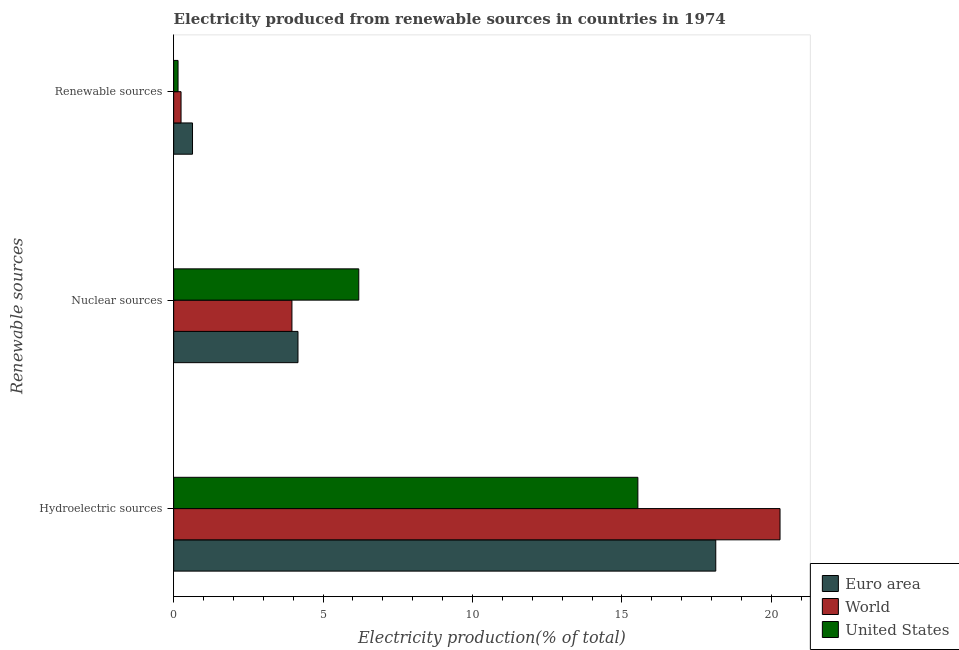Are the number of bars on each tick of the Y-axis equal?
Make the answer very short. Yes. How many bars are there on the 2nd tick from the top?
Provide a succinct answer. 3. What is the label of the 2nd group of bars from the top?
Give a very brief answer. Nuclear sources. What is the percentage of electricity produced by hydroelectric sources in United States?
Provide a short and direct response. 15.54. Across all countries, what is the maximum percentage of electricity produced by renewable sources?
Your response must be concise. 0.63. Across all countries, what is the minimum percentage of electricity produced by nuclear sources?
Your answer should be very brief. 3.96. In which country was the percentage of electricity produced by nuclear sources minimum?
Offer a terse response. World. What is the total percentage of electricity produced by renewable sources in the graph?
Keep it short and to the point. 1.02. What is the difference between the percentage of electricity produced by nuclear sources in Euro area and that in United States?
Provide a short and direct response. -2.03. What is the difference between the percentage of electricity produced by nuclear sources in World and the percentage of electricity produced by hydroelectric sources in Euro area?
Your response must be concise. -14.18. What is the average percentage of electricity produced by hydroelectric sources per country?
Provide a short and direct response. 17.99. What is the difference between the percentage of electricity produced by renewable sources and percentage of electricity produced by hydroelectric sources in Euro area?
Your response must be concise. -17.51. What is the ratio of the percentage of electricity produced by hydroelectric sources in United States to that in Euro area?
Provide a succinct answer. 0.86. Is the percentage of electricity produced by hydroelectric sources in United States less than that in Euro area?
Offer a very short reply. Yes. What is the difference between the highest and the second highest percentage of electricity produced by renewable sources?
Offer a terse response. 0.38. What is the difference between the highest and the lowest percentage of electricity produced by renewable sources?
Offer a terse response. 0.48. In how many countries, is the percentage of electricity produced by renewable sources greater than the average percentage of electricity produced by renewable sources taken over all countries?
Make the answer very short. 1. What does the 3rd bar from the bottom in Nuclear sources represents?
Offer a terse response. United States. Are all the bars in the graph horizontal?
Give a very brief answer. Yes. How many countries are there in the graph?
Your response must be concise. 3. What is the difference between two consecutive major ticks on the X-axis?
Your response must be concise. 5. Does the graph contain any zero values?
Give a very brief answer. No. Does the graph contain grids?
Keep it short and to the point. No. How many legend labels are there?
Your response must be concise. 3. What is the title of the graph?
Your answer should be very brief. Electricity produced from renewable sources in countries in 1974. Does "Central African Republic" appear as one of the legend labels in the graph?
Your response must be concise. No. What is the label or title of the Y-axis?
Provide a short and direct response. Renewable sources. What is the Electricity production(% of total) of Euro area in Hydroelectric sources?
Provide a succinct answer. 18.14. What is the Electricity production(% of total) in World in Hydroelectric sources?
Ensure brevity in your answer.  20.29. What is the Electricity production(% of total) in United States in Hydroelectric sources?
Make the answer very short. 15.54. What is the Electricity production(% of total) in Euro area in Nuclear sources?
Ensure brevity in your answer.  4.16. What is the Electricity production(% of total) in World in Nuclear sources?
Your answer should be compact. 3.96. What is the Electricity production(% of total) in United States in Nuclear sources?
Provide a short and direct response. 6.19. What is the Electricity production(% of total) of Euro area in Renewable sources?
Offer a terse response. 0.63. What is the Electricity production(% of total) in World in Renewable sources?
Offer a very short reply. 0.25. What is the Electricity production(% of total) of United States in Renewable sources?
Your answer should be compact. 0.15. Across all Renewable sources, what is the maximum Electricity production(% of total) in Euro area?
Your response must be concise. 18.14. Across all Renewable sources, what is the maximum Electricity production(% of total) in World?
Ensure brevity in your answer.  20.29. Across all Renewable sources, what is the maximum Electricity production(% of total) of United States?
Make the answer very short. 15.54. Across all Renewable sources, what is the minimum Electricity production(% of total) of Euro area?
Keep it short and to the point. 0.63. Across all Renewable sources, what is the minimum Electricity production(% of total) in World?
Your answer should be compact. 0.25. Across all Renewable sources, what is the minimum Electricity production(% of total) in United States?
Make the answer very short. 0.15. What is the total Electricity production(% of total) of Euro area in the graph?
Give a very brief answer. 22.93. What is the total Electricity production(% of total) in World in the graph?
Your answer should be very brief. 24.5. What is the total Electricity production(% of total) of United States in the graph?
Offer a terse response. 21.88. What is the difference between the Electricity production(% of total) of Euro area in Hydroelectric sources and that in Nuclear sources?
Keep it short and to the point. 13.98. What is the difference between the Electricity production(% of total) of World in Hydroelectric sources and that in Nuclear sources?
Your answer should be compact. 16.33. What is the difference between the Electricity production(% of total) of United States in Hydroelectric sources and that in Nuclear sources?
Ensure brevity in your answer.  9.34. What is the difference between the Electricity production(% of total) in Euro area in Hydroelectric sources and that in Renewable sources?
Give a very brief answer. 17.51. What is the difference between the Electricity production(% of total) in World in Hydroelectric sources and that in Renewable sources?
Ensure brevity in your answer.  20.05. What is the difference between the Electricity production(% of total) of United States in Hydroelectric sources and that in Renewable sources?
Ensure brevity in your answer.  15.39. What is the difference between the Electricity production(% of total) of Euro area in Nuclear sources and that in Renewable sources?
Give a very brief answer. 3.53. What is the difference between the Electricity production(% of total) of World in Nuclear sources and that in Renewable sources?
Ensure brevity in your answer.  3.71. What is the difference between the Electricity production(% of total) of United States in Nuclear sources and that in Renewable sources?
Provide a short and direct response. 6.05. What is the difference between the Electricity production(% of total) in Euro area in Hydroelectric sources and the Electricity production(% of total) in World in Nuclear sources?
Provide a succinct answer. 14.18. What is the difference between the Electricity production(% of total) of Euro area in Hydroelectric sources and the Electricity production(% of total) of United States in Nuclear sources?
Provide a short and direct response. 11.95. What is the difference between the Electricity production(% of total) of World in Hydroelectric sources and the Electricity production(% of total) of United States in Nuclear sources?
Offer a very short reply. 14.1. What is the difference between the Electricity production(% of total) of Euro area in Hydroelectric sources and the Electricity production(% of total) of World in Renewable sources?
Provide a succinct answer. 17.89. What is the difference between the Electricity production(% of total) in Euro area in Hydroelectric sources and the Electricity production(% of total) in United States in Renewable sources?
Give a very brief answer. 18. What is the difference between the Electricity production(% of total) of World in Hydroelectric sources and the Electricity production(% of total) of United States in Renewable sources?
Provide a succinct answer. 20.15. What is the difference between the Electricity production(% of total) of Euro area in Nuclear sources and the Electricity production(% of total) of World in Renewable sources?
Make the answer very short. 3.91. What is the difference between the Electricity production(% of total) of Euro area in Nuclear sources and the Electricity production(% of total) of United States in Renewable sources?
Provide a short and direct response. 4.01. What is the difference between the Electricity production(% of total) in World in Nuclear sources and the Electricity production(% of total) in United States in Renewable sources?
Give a very brief answer. 3.81. What is the average Electricity production(% of total) in Euro area per Renewable sources?
Give a very brief answer. 7.64. What is the average Electricity production(% of total) in World per Renewable sources?
Offer a terse response. 8.17. What is the average Electricity production(% of total) in United States per Renewable sources?
Provide a succinct answer. 7.29. What is the difference between the Electricity production(% of total) of Euro area and Electricity production(% of total) of World in Hydroelectric sources?
Make the answer very short. -2.15. What is the difference between the Electricity production(% of total) in Euro area and Electricity production(% of total) in United States in Hydroelectric sources?
Your response must be concise. 2.61. What is the difference between the Electricity production(% of total) of World and Electricity production(% of total) of United States in Hydroelectric sources?
Make the answer very short. 4.76. What is the difference between the Electricity production(% of total) of Euro area and Electricity production(% of total) of World in Nuclear sources?
Provide a succinct answer. 0.2. What is the difference between the Electricity production(% of total) of Euro area and Electricity production(% of total) of United States in Nuclear sources?
Ensure brevity in your answer.  -2.03. What is the difference between the Electricity production(% of total) in World and Electricity production(% of total) in United States in Nuclear sources?
Provide a short and direct response. -2.24. What is the difference between the Electricity production(% of total) of Euro area and Electricity production(% of total) of World in Renewable sources?
Offer a terse response. 0.38. What is the difference between the Electricity production(% of total) in Euro area and Electricity production(% of total) in United States in Renewable sources?
Provide a short and direct response. 0.48. What is the difference between the Electricity production(% of total) in World and Electricity production(% of total) in United States in Renewable sources?
Provide a short and direct response. 0.1. What is the ratio of the Electricity production(% of total) in Euro area in Hydroelectric sources to that in Nuclear sources?
Your answer should be compact. 4.36. What is the ratio of the Electricity production(% of total) in World in Hydroelectric sources to that in Nuclear sources?
Keep it short and to the point. 5.13. What is the ratio of the Electricity production(% of total) in United States in Hydroelectric sources to that in Nuclear sources?
Ensure brevity in your answer.  2.51. What is the ratio of the Electricity production(% of total) of Euro area in Hydroelectric sources to that in Renewable sources?
Your response must be concise. 28.78. What is the ratio of the Electricity production(% of total) of World in Hydroelectric sources to that in Renewable sources?
Offer a terse response. 82.24. What is the ratio of the Electricity production(% of total) of United States in Hydroelectric sources to that in Renewable sources?
Your answer should be compact. 106.17. What is the ratio of the Electricity production(% of total) of Euro area in Nuclear sources to that in Renewable sources?
Offer a very short reply. 6.6. What is the ratio of the Electricity production(% of total) in World in Nuclear sources to that in Renewable sources?
Your response must be concise. 16.04. What is the ratio of the Electricity production(% of total) in United States in Nuclear sources to that in Renewable sources?
Give a very brief answer. 42.34. What is the difference between the highest and the second highest Electricity production(% of total) in Euro area?
Offer a very short reply. 13.98. What is the difference between the highest and the second highest Electricity production(% of total) in World?
Make the answer very short. 16.33. What is the difference between the highest and the second highest Electricity production(% of total) of United States?
Give a very brief answer. 9.34. What is the difference between the highest and the lowest Electricity production(% of total) in Euro area?
Provide a short and direct response. 17.51. What is the difference between the highest and the lowest Electricity production(% of total) of World?
Offer a very short reply. 20.05. What is the difference between the highest and the lowest Electricity production(% of total) of United States?
Offer a terse response. 15.39. 